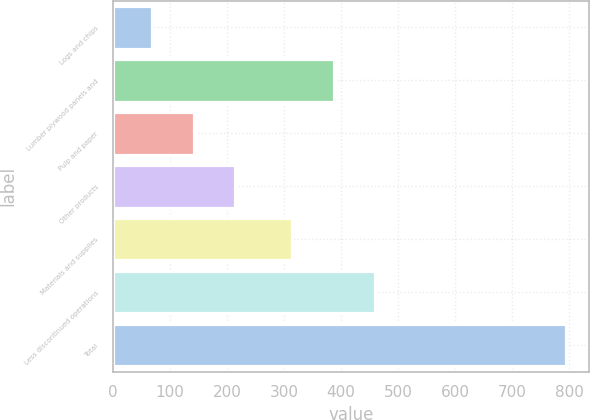Convert chart. <chart><loc_0><loc_0><loc_500><loc_500><bar_chart><fcel>Logs and chips<fcel>Lumber plywood panels and<fcel>Pulp and paper<fcel>Other products<fcel>Materials and supplies<fcel>Less discontinued operations<fcel>Total<nl><fcel>69<fcel>387.6<fcel>141.6<fcel>214.2<fcel>315<fcel>460.2<fcel>795<nl></chart> 